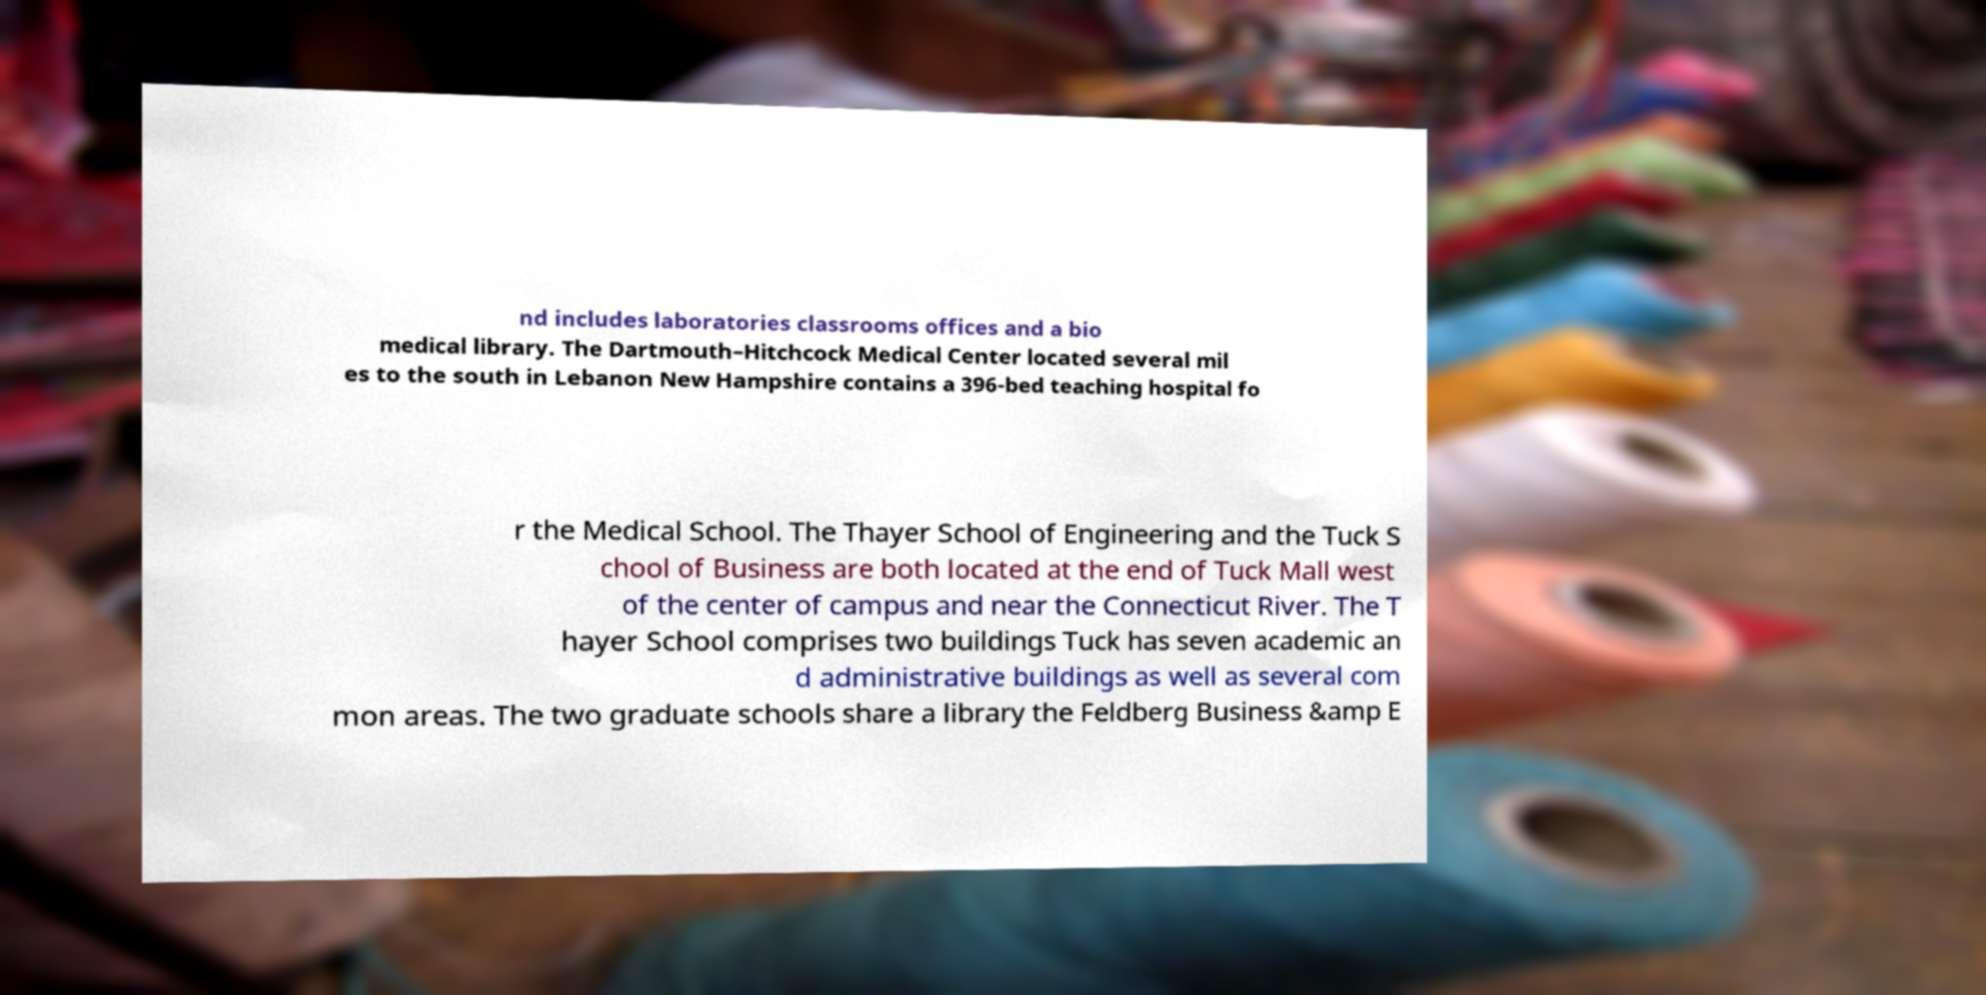Can you read and provide the text displayed in the image?This photo seems to have some interesting text. Can you extract and type it out for me? nd includes laboratories classrooms offices and a bio medical library. The Dartmouth–Hitchcock Medical Center located several mil es to the south in Lebanon New Hampshire contains a 396-bed teaching hospital fo r the Medical School. The Thayer School of Engineering and the Tuck S chool of Business are both located at the end of Tuck Mall west of the center of campus and near the Connecticut River. The T hayer School comprises two buildings Tuck has seven academic an d administrative buildings as well as several com mon areas. The two graduate schools share a library the Feldberg Business &amp E 